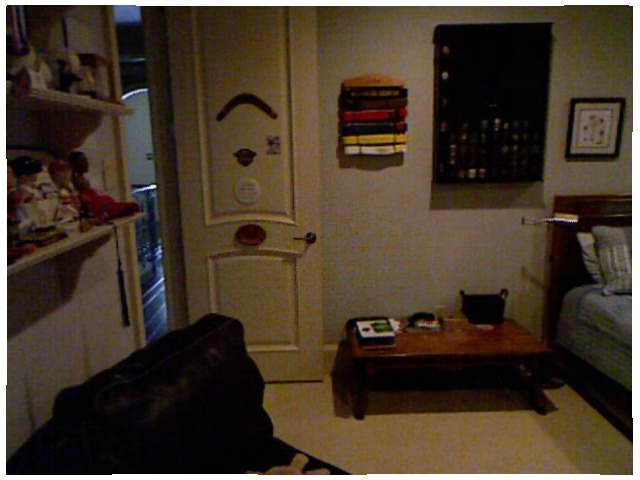<image>
Can you confirm if the bed is under the door? No. The bed is not positioned under the door. The vertical relationship between these objects is different. Where is the bed in relation to the table? Is it in front of the table? No. The bed is not in front of the table. The spatial positioning shows a different relationship between these objects. Is the boomerang on the door? Yes. Looking at the image, I can see the boomerang is positioned on top of the door, with the door providing support. Where is the boomerang in relation to the wall? Is it on the wall? No. The boomerang is not positioned on the wall. They may be near each other, but the boomerang is not supported by or resting on top of the wall. 